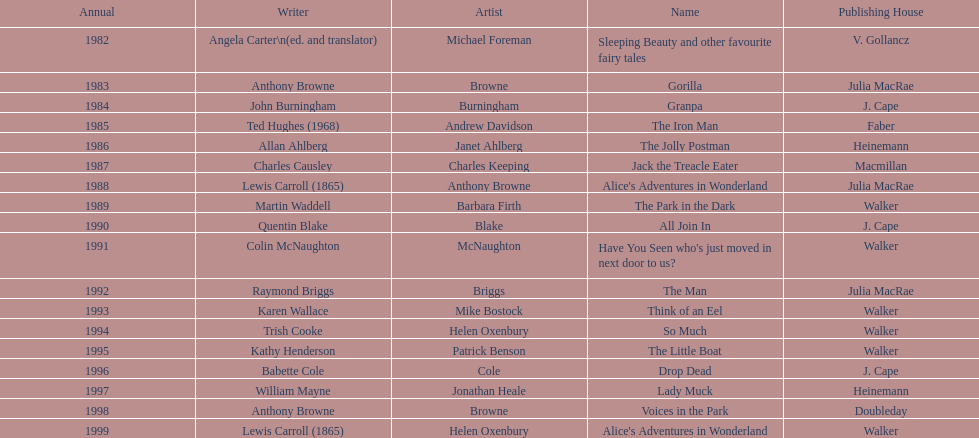Which title was after the year 1991 but before the year 1993? The Man. 